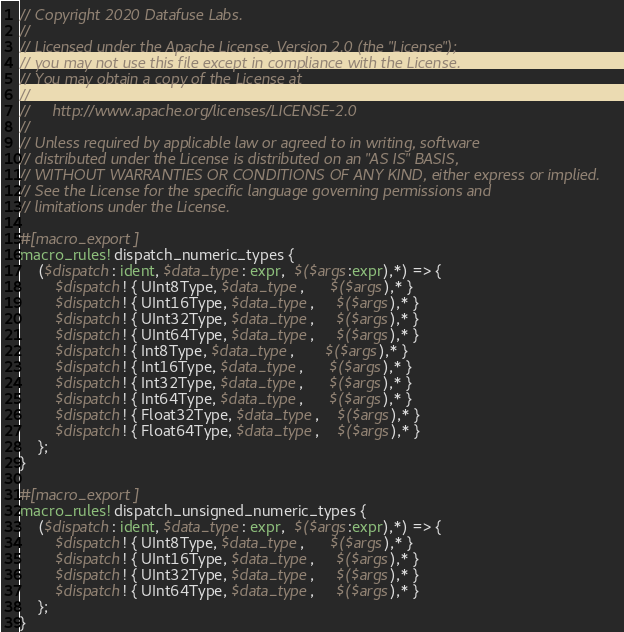Convert code to text. <code><loc_0><loc_0><loc_500><loc_500><_Rust_>// Copyright 2020 Datafuse Labs.
//
// Licensed under the Apache License, Version 2.0 (the "License");
// you may not use this file except in compliance with the License.
// You may obtain a copy of the License at
//
//     http://www.apache.org/licenses/LICENSE-2.0
//
// Unless required by applicable law or agreed to in writing, software
// distributed under the License is distributed on an "AS IS" BASIS,
// WITHOUT WARRANTIES OR CONDITIONS OF ANY KIND, either express or implied.
// See the License for the specific language governing permissions and
// limitations under the License.

#[macro_export]
macro_rules! dispatch_numeric_types {
    ($dispatch: ident, $data_type: expr,  $($args:expr),*) => {
        $dispatch! { UInt8Type, $data_type,      $($args),* }
        $dispatch! { UInt16Type, $data_type,     $($args),* }
        $dispatch! { UInt32Type, $data_type,     $($args),* }
        $dispatch! { UInt64Type, $data_type,     $($args),* }
        $dispatch! { Int8Type, $data_type,       $($args),* }
        $dispatch! { Int16Type, $data_type,      $($args),* }
        $dispatch! { Int32Type, $data_type,      $($args),* }
        $dispatch! { Int64Type, $data_type,      $($args),* }
        $dispatch! { Float32Type, $data_type,    $($args),* }
        $dispatch! { Float64Type, $data_type,    $($args),* }
    };
}

#[macro_export]
macro_rules! dispatch_unsigned_numeric_types {
    ($dispatch: ident, $data_type: expr,  $($args:expr),*) => {
        $dispatch! { UInt8Type, $data_type,      $($args),* }
        $dispatch! { UInt16Type, $data_type,     $($args),* }
        $dispatch! { UInt32Type, $data_type,     $($args),* }
        $dispatch! { UInt64Type, $data_type,     $($args),* }
    };
}
</code> 